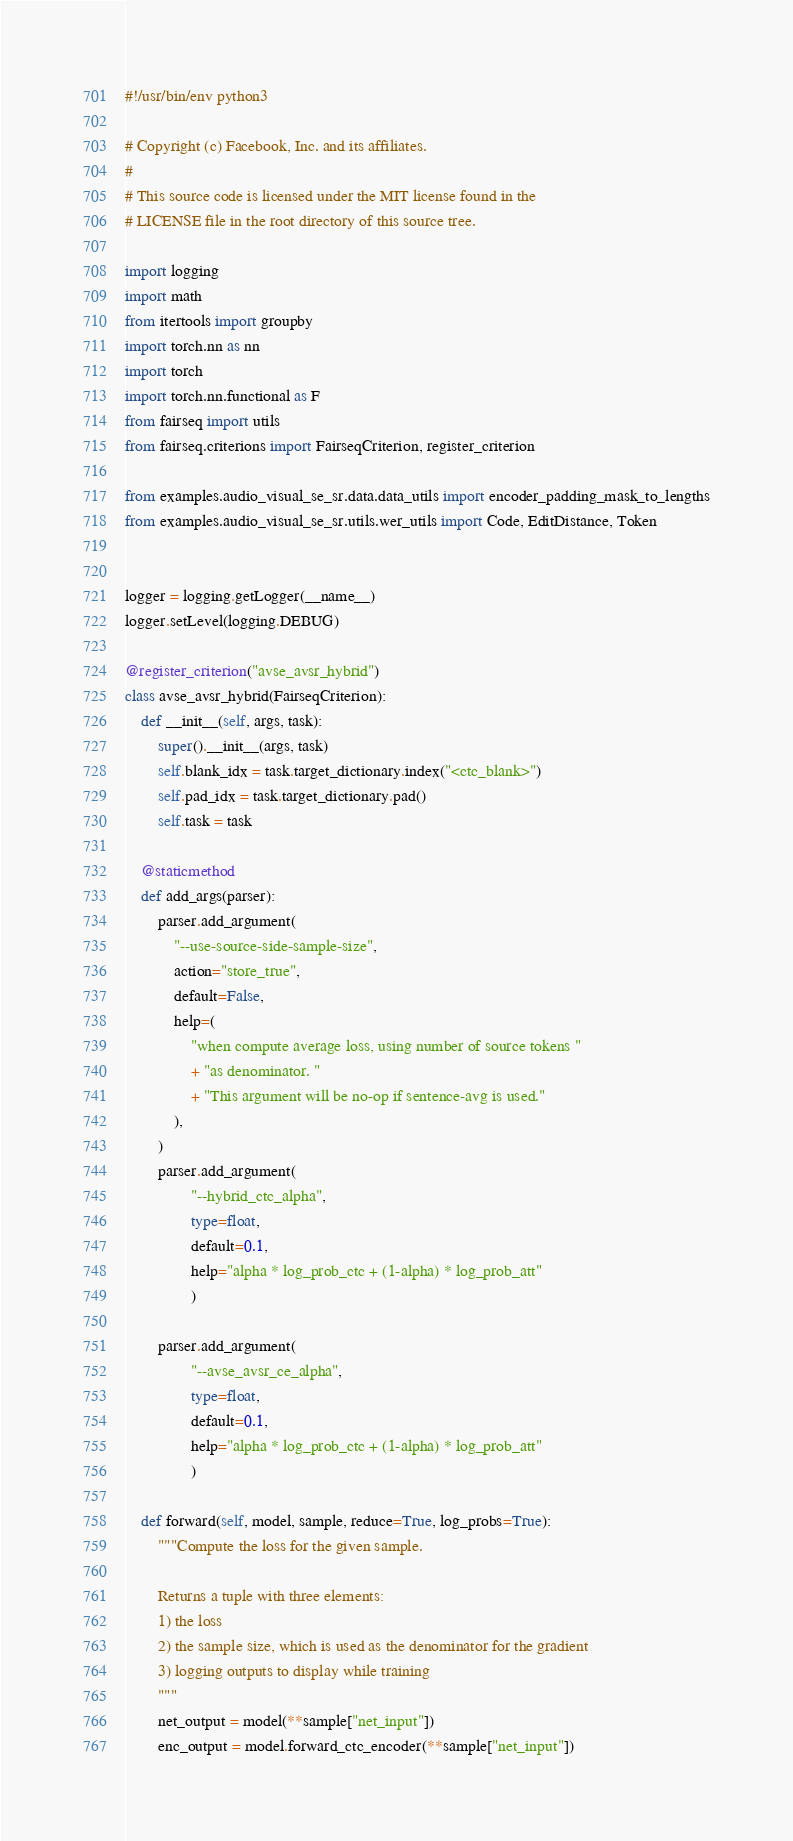Convert code to text. <code><loc_0><loc_0><loc_500><loc_500><_Python_>#!/usr/bin/env python3

# Copyright (c) Facebook, Inc. and its affiliates.
#
# This source code is licensed under the MIT license found in the
# LICENSE file in the root directory of this source tree.

import logging
import math
from itertools import groupby
import torch.nn as nn
import torch
import torch.nn.functional as F
from fairseq import utils
from fairseq.criterions import FairseqCriterion, register_criterion

from examples.audio_visual_se_sr.data.data_utils import encoder_padding_mask_to_lengths
from examples.audio_visual_se_sr.utils.wer_utils import Code, EditDistance, Token


logger = logging.getLogger(__name__)
logger.setLevel(logging.DEBUG)

@register_criterion("avse_avsr_hybrid")
class avse_avsr_hybrid(FairseqCriterion):
    def __init__(self, args, task):
        super().__init__(args, task)
        self.blank_idx = task.target_dictionary.index("<ctc_blank>")
        self.pad_idx = task.target_dictionary.pad()
        self.task = task

    @staticmethod
    def add_args(parser):
        parser.add_argument(
            "--use-source-side-sample-size",
            action="store_true",
            default=False,
            help=(
                "when compute average loss, using number of source tokens "
                + "as denominator. "
                + "This argument will be no-op if sentence-avg is used."
            ),
        )
        parser.add_argument(
                "--hybrid_ctc_alpha",
                type=float,
                default=0.1,
                help="alpha * log_prob_ctc + (1-alpha) * log_prob_att"
                )
        
        parser.add_argument(
                "--avse_avsr_ce_alpha",
                type=float,
                default=0.1,
                help="alpha * log_prob_ctc + (1-alpha) * log_prob_att"
                )

    def forward(self, model, sample, reduce=True, log_probs=True):
        """Compute the loss for the given sample.

        Returns a tuple with three elements:
        1) the loss
        2) the sample size, which is used as the denominator for the gradient
        3) logging outputs to display while training
        """
        net_output = model(**sample["net_input"])
        enc_output = model.forward_ctc_encoder(**sample["net_input"])</code> 